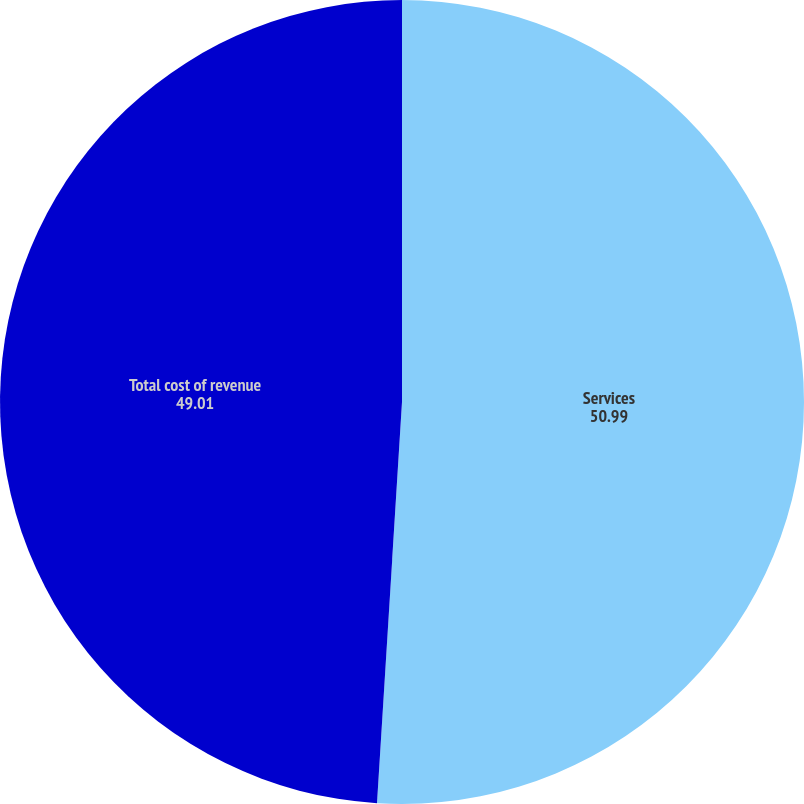Convert chart to OTSL. <chart><loc_0><loc_0><loc_500><loc_500><pie_chart><fcel>Services<fcel>Total cost of revenue<nl><fcel>50.99%<fcel>49.01%<nl></chart> 